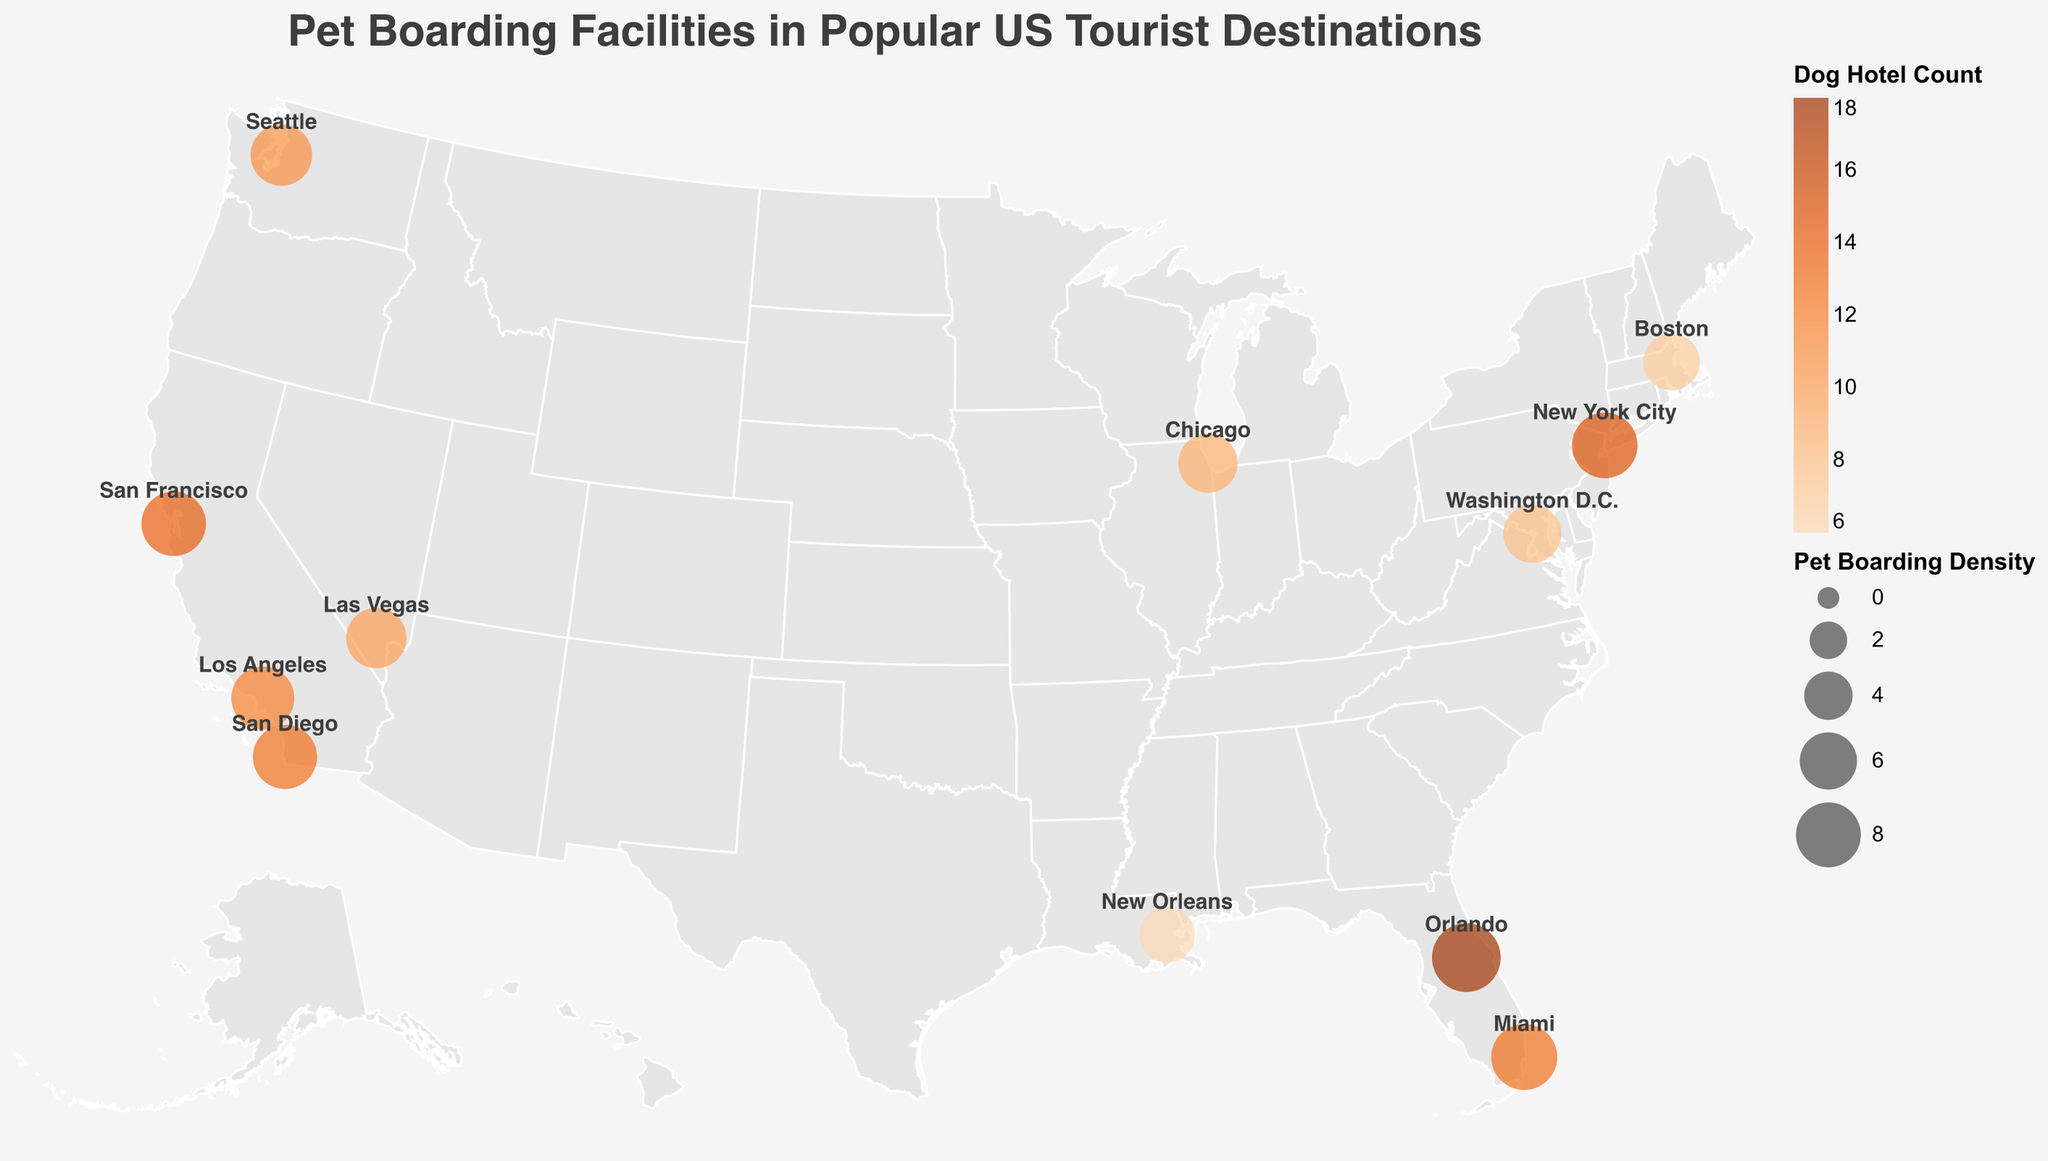How many cities are displayed in the plot? Count the number of distinct circles representing cities in the map.
Answer: 12 Which city has the highest pet boarding density? Look at the size of the circles; the largest circle indicates the highest pet boarding density. The tooltips can also provide exact values.
Answer: Orlando How does the pet boarding density of Chicago compare to that of Boston? Compare the size of the circles for Chicago and Boston; the tooltip also gives exact values: Chicago (6.5) and Boston (5.9).
Answer: Higher in Chicago What's the total number of dog hotels across all listed cities? Sum up the Dog_Hotel_Count values for all cities: 15+12+18+10+14+9+13+8+7+6+11+13.
Answer: 136 Which city is represented with the darkest orange circle, indicating the highest number of dog hotels? The color intensity corresponds to the number of dog hotels. The darkest orange circle indicates the highest count. The tooltip can be used for verification.
Answer: Orlando Is there a city with both a high tourist popularity score and a low pet boarding density? Check for a city with a high Tourist_Popularity_Score (near 95) and a smaller circle size. The tooltip helps here. Note: Washington D.C. has a high score (77) but low density (6.2).
Answer: Washington D.C What similarities do Miami and Orlando have in this dataset? Compare attributes of both cities: Both have high pet boarding density (Miami: 8.3, Orlando: 9.1) and are in Florida. Both also have high Dog_Hotel_Count (Miami: 13, Orlando: 18).
Answer: High density and hotel count; both in FL Which city has the closest average pet boarding density to the overall average of all cities? Calculate the average pet boarding density: (8.2 + 7.5 + 9.1 + 6.8 + 7.9 + 6.5 + 8.3 + 6.2 + 5.9 + 5.6 + 7.1 + 7.8) / 12 = 7.2. Compare each city's density to this average.
Answer: Seattle and San Francisco (7.1 and 7.9) Which city stands out the most in terms of tourist popularity, and how does its pet boarding density reflect on that? Identify the city with the highest Tourist_Popularity_Score using the tooltips. Check the corresponding pet boarding density.
Answer: New York City; high popularity (95) and high density (8.2) 